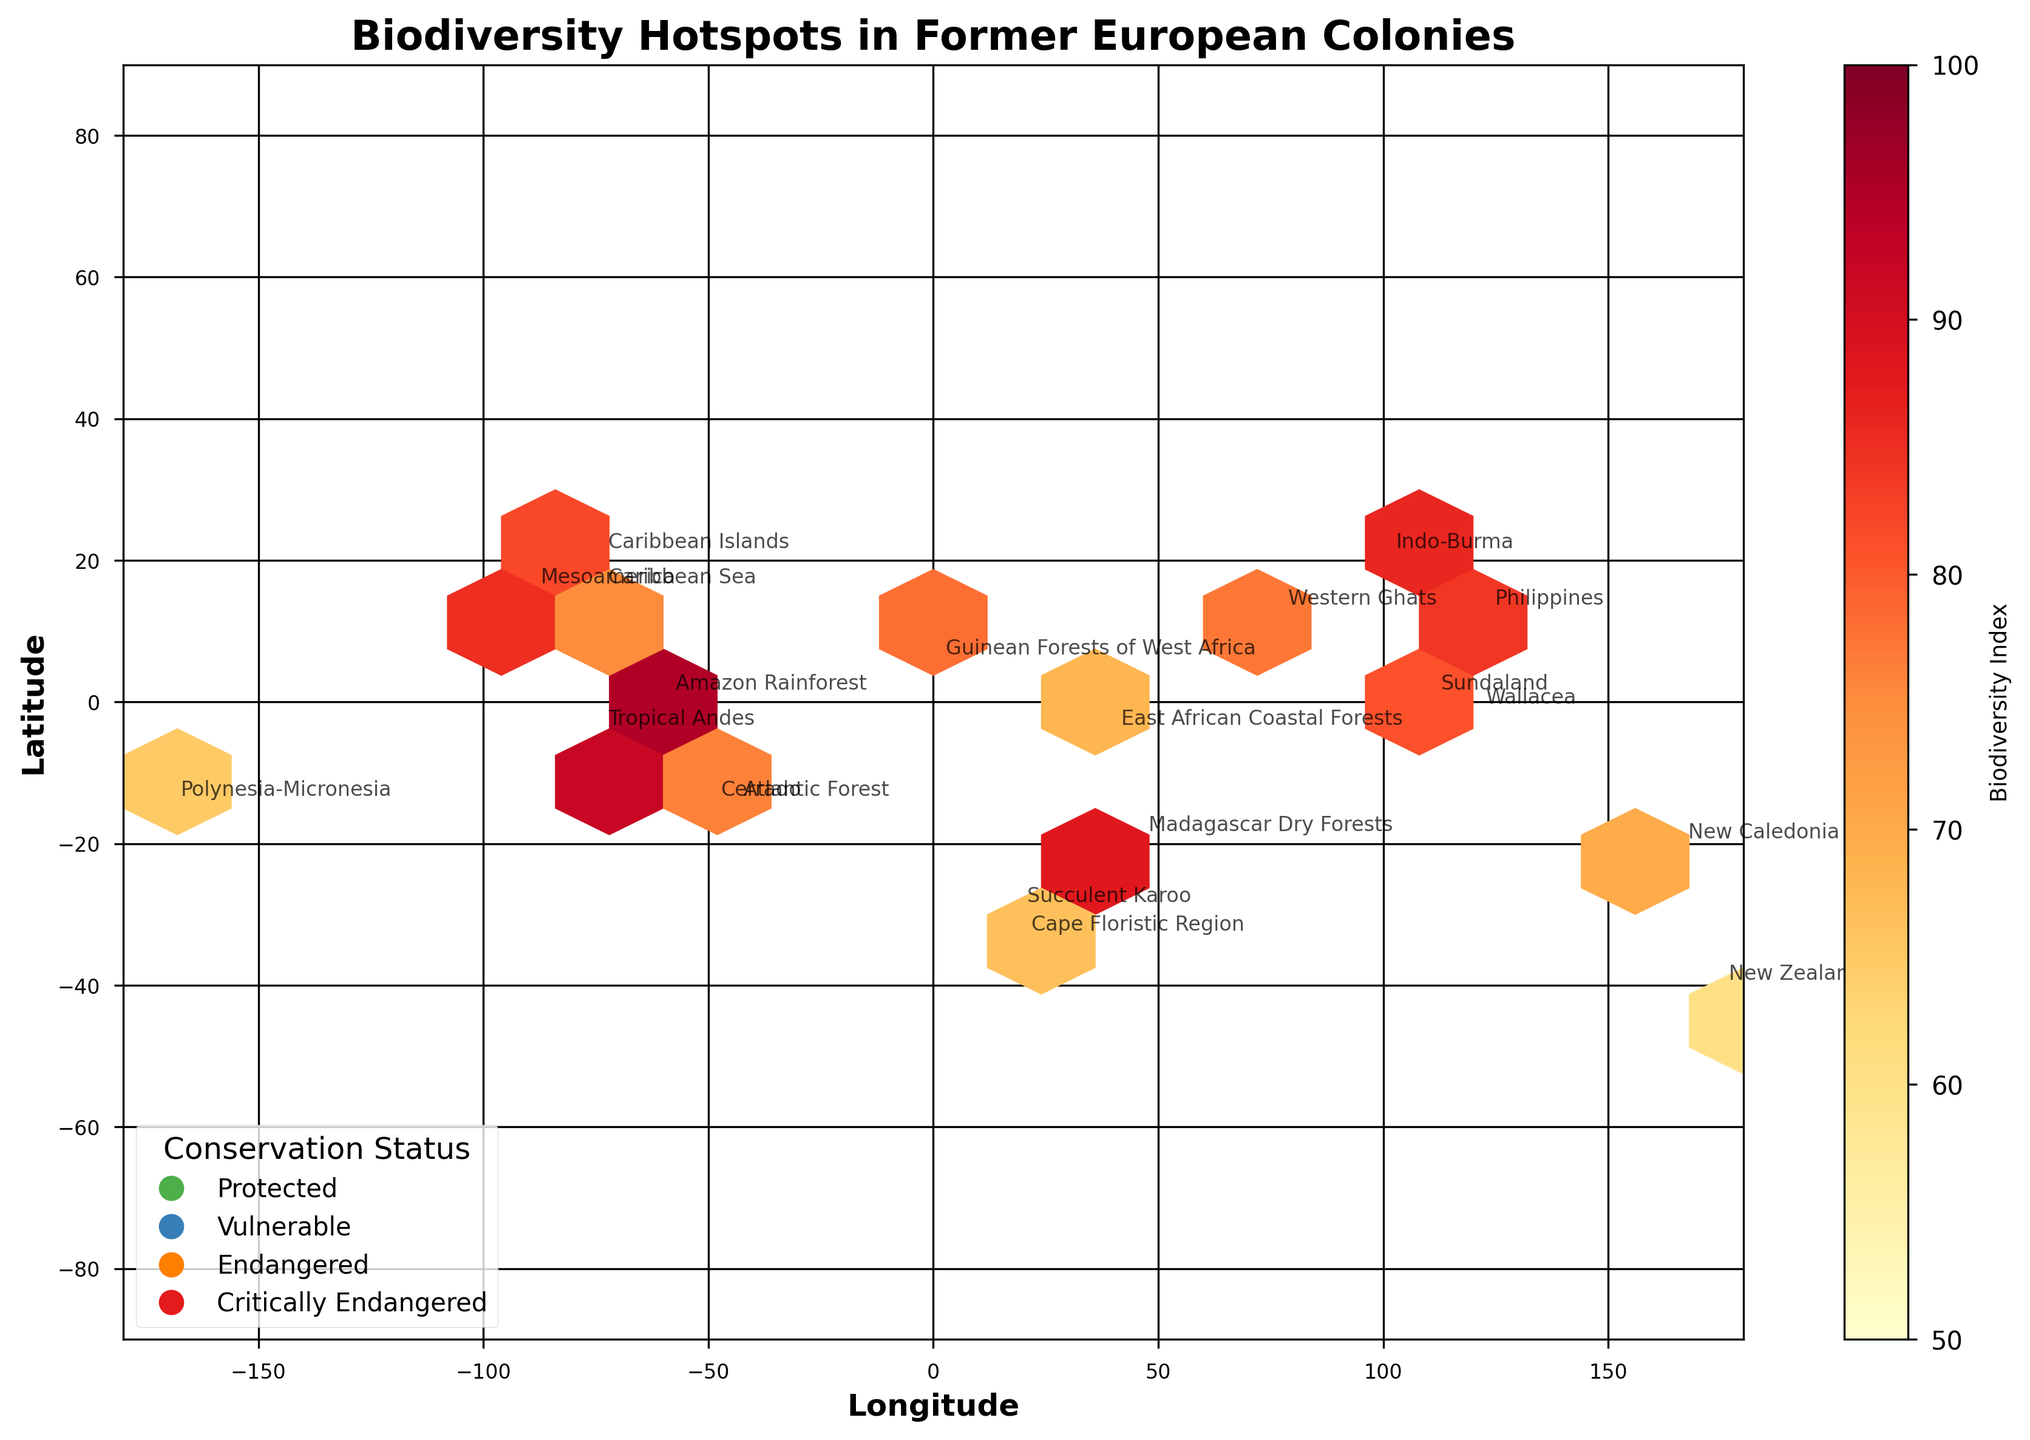What is the title of the figure? The title of the figure is displayed at the top center. It provides an overarching description of what the plot represents.
Answer: Biodiversity Hotspots in Former European Colonies How many data points represent ecosystems in the Southern Hemisphere? To determine this, examine the latitude axis (y-axis) for values less than zero, then count the annotated ecosystems within this range.
Answer: 10 Which ecosystem has the highest biodiversity index, and what is its conservation status? Locate the ecosystem with the highest number in the color bar (Biodiversity Index) and refer to its annotation for the conservation status.
Answer: Amazon Rainforest, Protected Is there a region with a critically endangered conservation status with a biodiversity index below 70? Check the legend for 'Critically Endangered' (red marker) and locate the corresponding annotations, then see if any have an index below 70.
Answer: Yes, New Caledonia How are the ecosystems in the Western Hemisphere distributed in terms of conservation status? Examine all ecosystems located west of the Prime Meridian (longitude < 0) and note their conservation statuses based on the legend and color markers.
Answer: More varied; includes Protected, Endangered, and Vulnerable statuses Which hemisphere has a higher concentration of critically endangered ecosystems? Identify ecosystems marked with the 'Critically Endangered' status (red markers) and count them in both hemispheres, comparing the totals.
Answer: Eastern Hemisphere Among the endangered ecosystems, which has the lowest biodiversity index, and what is its latitude and longitude? Filter endangered ecosystems by using the appropriate color (Orange); then identify the one with the lowest index and check its geographical coordinates.
Answer: Polynesia-Micronesia, Latitude: -15, Longitude: -170 